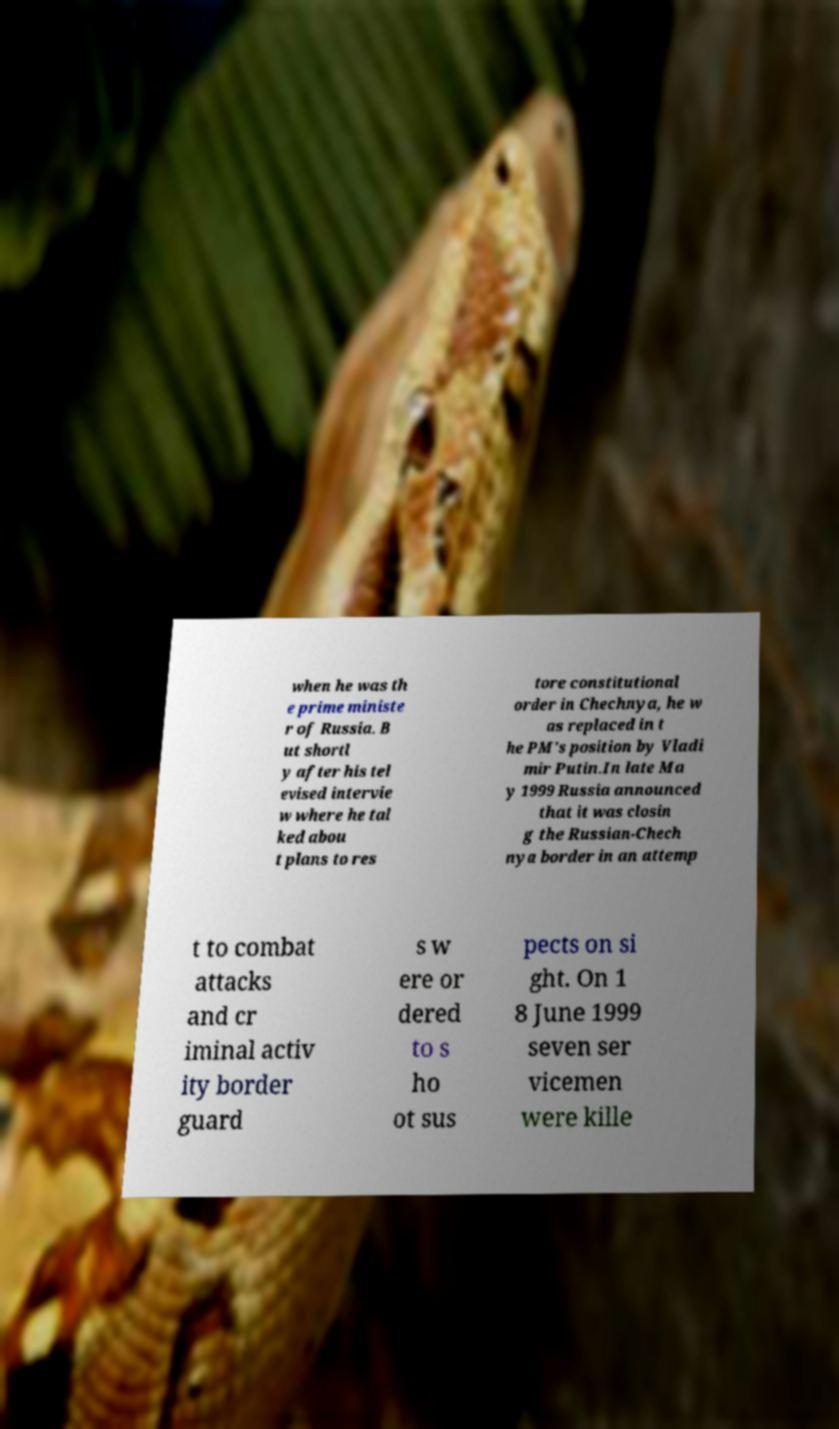Please read and relay the text visible in this image. What does it say? when he was th e prime ministe r of Russia. B ut shortl y after his tel evised intervie w where he tal ked abou t plans to res tore constitutional order in Chechnya, he w as replaced in t he PM's position by Vladi mir Putin.In late Ma y 1999 Russia announced that it was closin g the Russian-Chech nya border in an attemp t to combat attacks and cr iminal activ ity border guard s w ere or dered to s ho ot sus pects on si ght. On 1 8 June 1999 seven ser vicemen were kille 